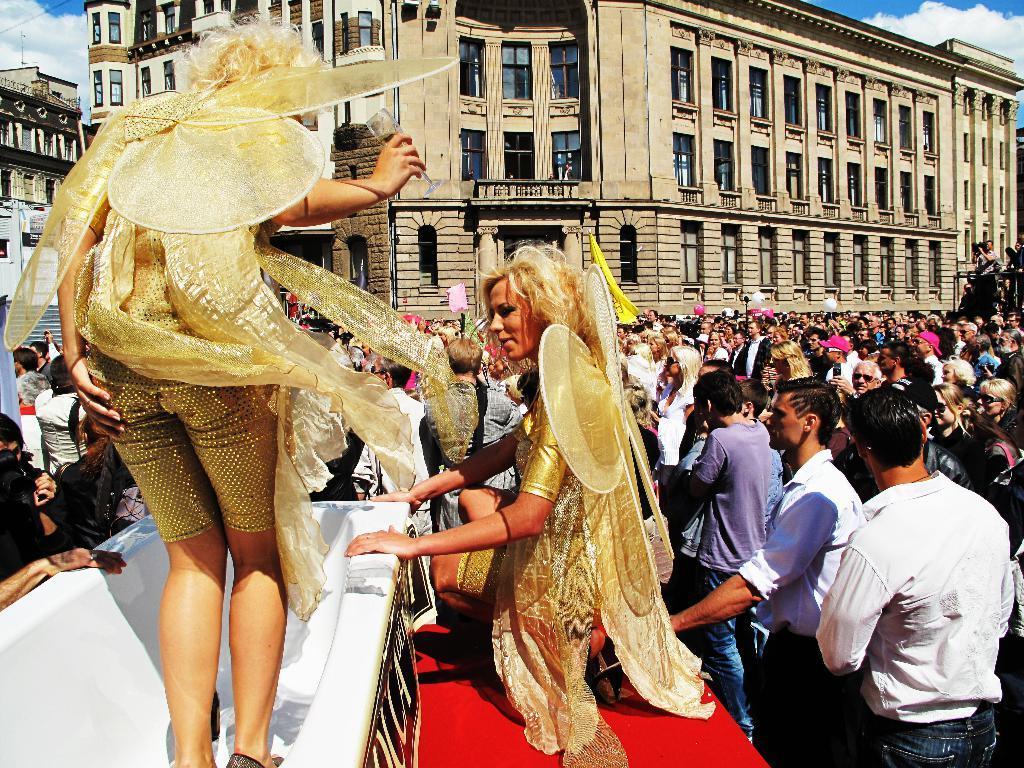Please provide a concise description of this image. In the foreground I can see two persons in costumes and one person is standing in a bath tub and red color surface. In the background I can see a crowd on the road, buildings, windows, wires, steps, vehicle and the sky. This image is taken may be during a day. 